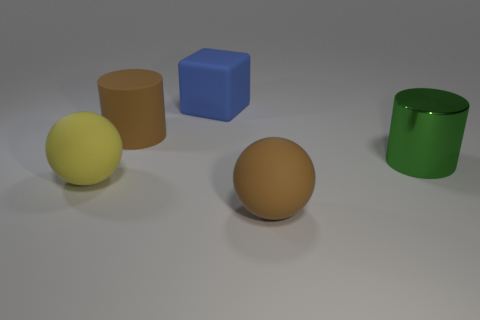Are the shadows consistent with one light source or multiple? The shadows are subtle and soft, but they appear consistent with a single light source, given their direction and softness. There's no evidence of multiple shadow directions that would indicate several light sources. How would you describe the composition of this image? The image is composed with a balance of shapes and colors that guides the viewer's eye across the scene. Objects are placed with space between them, allowing each to stand out. The use of three basic geometric shapes (cube, spheres, cylinder) and primary colors creates a simple yet dynamic composition. 